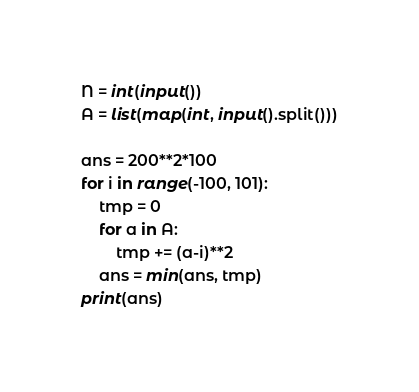Convert code to text. <code><loc_0><loc_0><loc_500><loc_500><_Python_>N = int(input())
A = list(map(int, input().split()))

ans = 200**2*100
for i in range(-100, 101):
    tmp = 0
    for a in A:
        tmp += (a-i)**2
    ans = min(ans, tmp)
print(ans)
</code> 